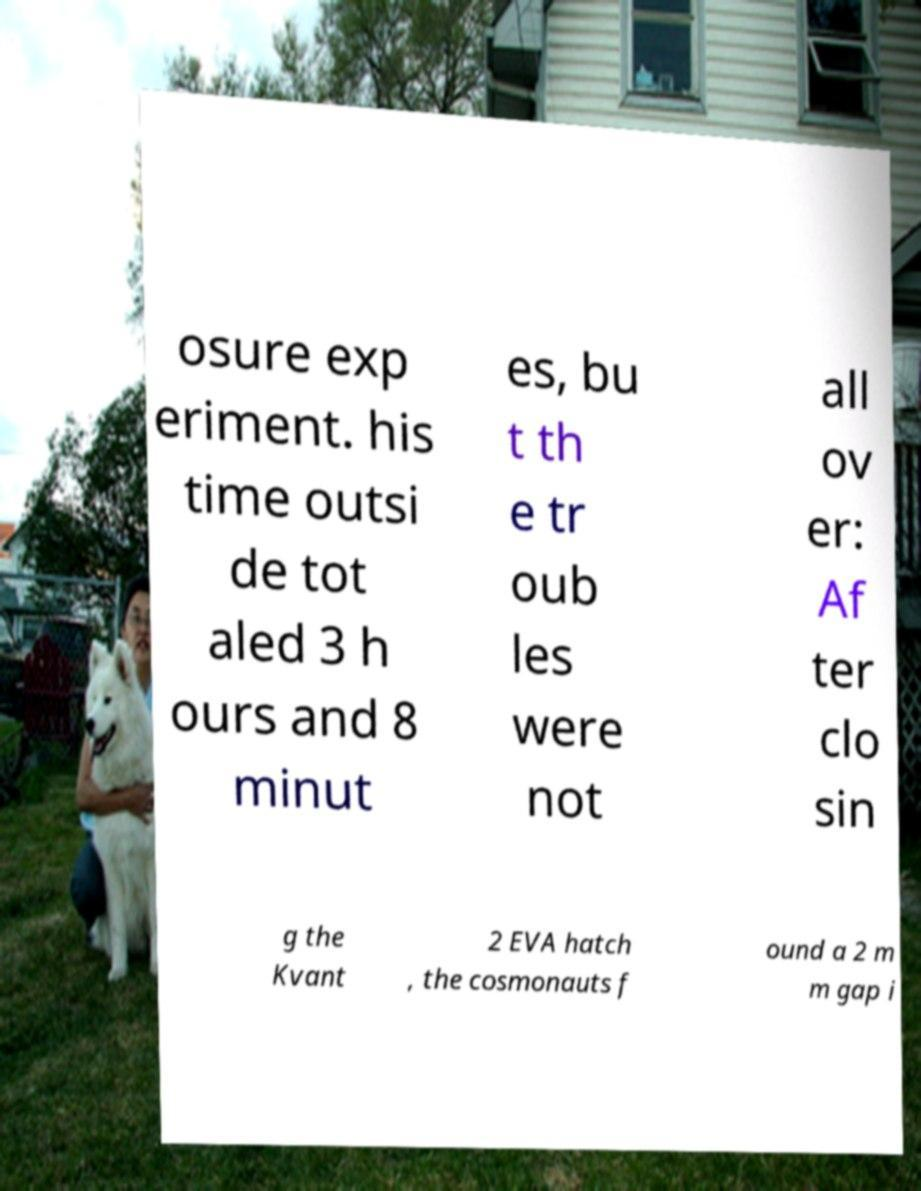Please identify and transcribe the text found in this image. osure exp eriment. his time outsi de tot aled 3 h ours and 8 minut es, bu t th e tr oub les were not all ov er: Af ter clo sin g the Kvant 2 EVA hatch , the cosmonauts f ound a 2 m m gap i 